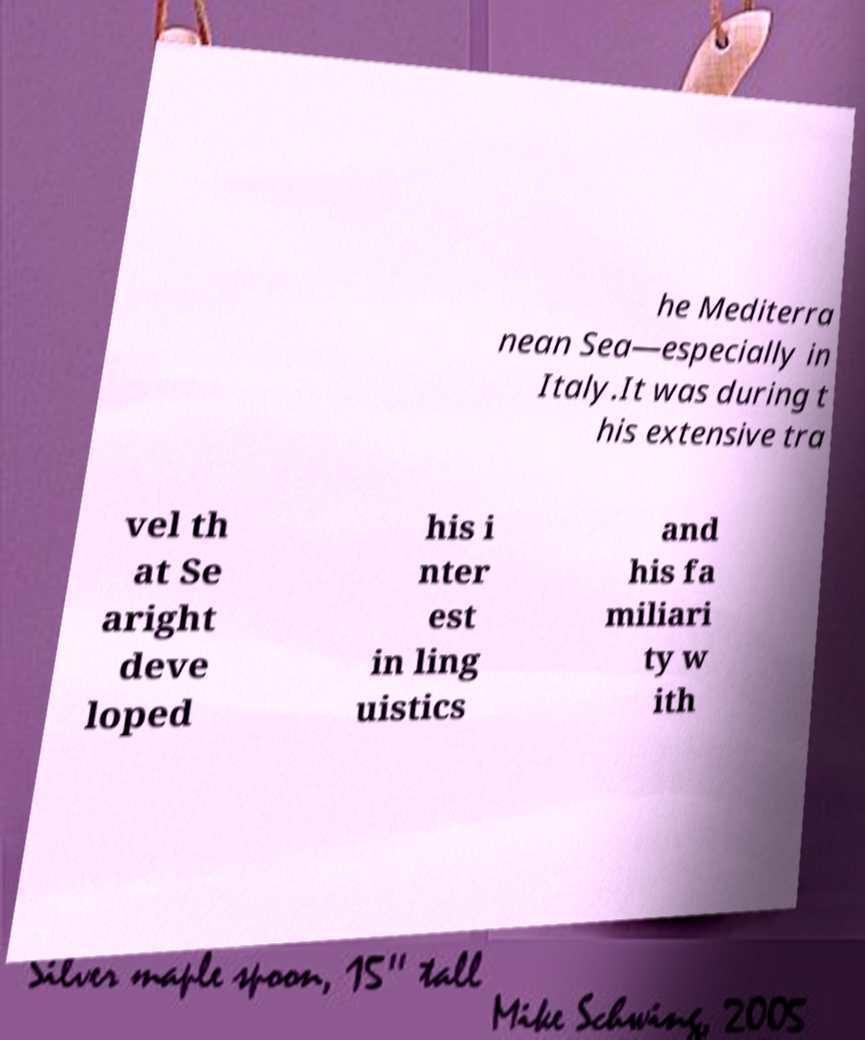What messages or text are displayed in this image? I need them in a readable, typed format. he Mediterra nean Sea—especially in Italy.It was during t his extensive tra vel th at Se aright deve loped his i nter est in ling uistics and his fa miliari ty w ith 